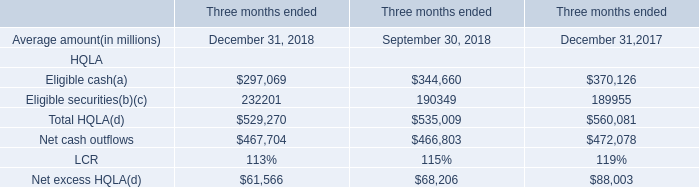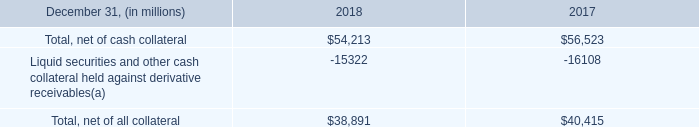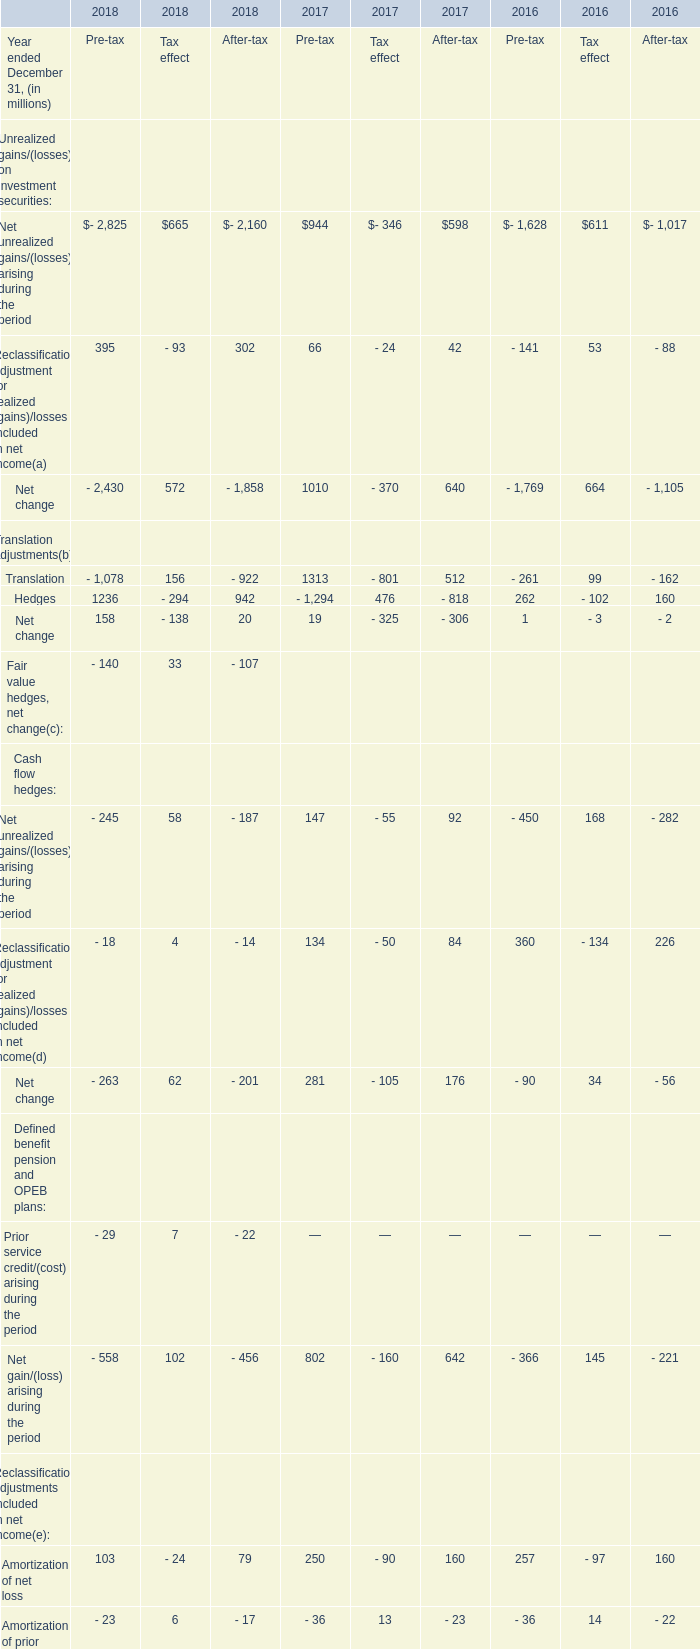Which year is Net unrealized gains/(losses) arising during the periodthe lowest? 
Answer: 2017. 